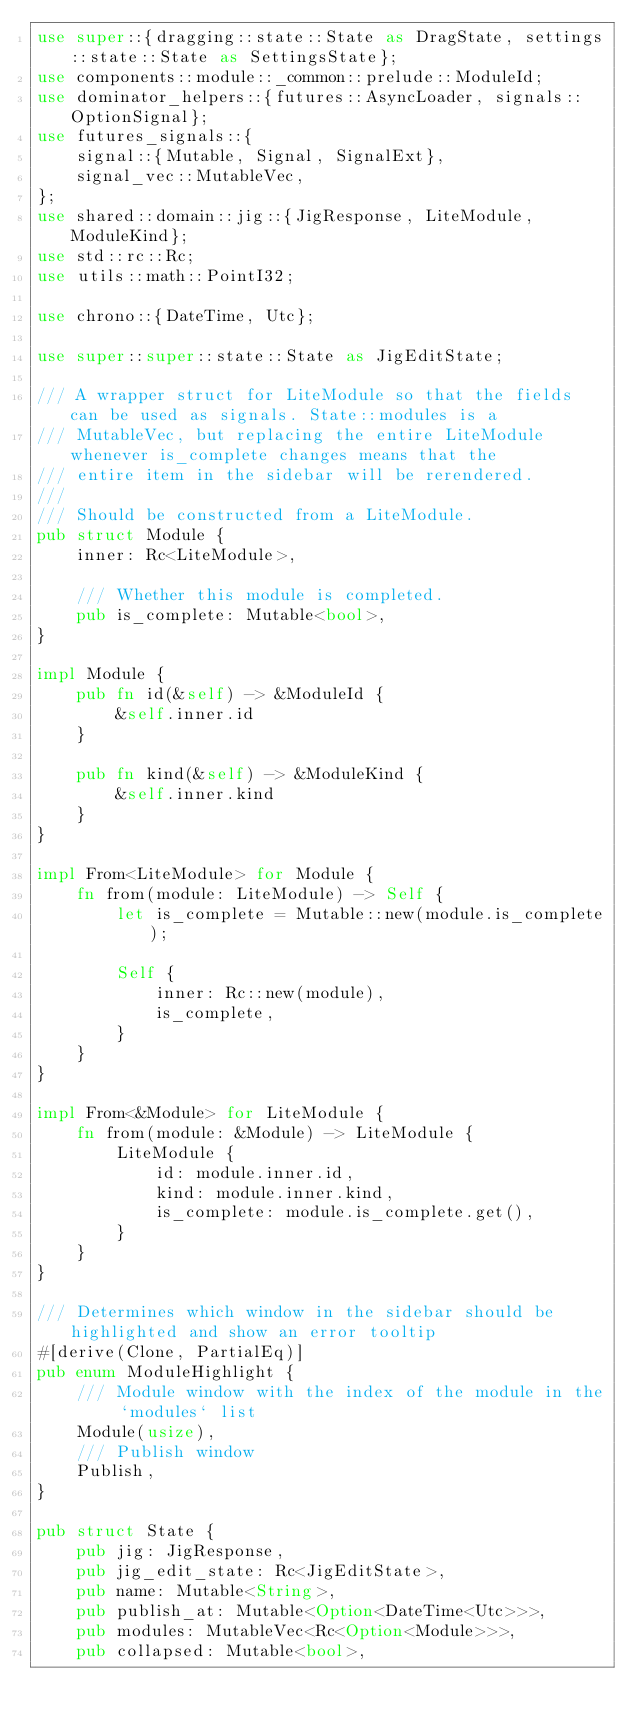<code> <loc_0><loc_0><loc_500><loc_500><_Rust_>use super::{dragging::state::State as DragState, settings::state::State as SettingsState};
use components::module::_common::prelude::ModuleId;
use dominator_helpers::{futures::AsyncLoader, signals::OptionSignal};
use futures_signals::{
    signal::{Mutable, Signal, SignalExt},
    signal_vec::MutableVec,
};
use shared::domain::jig::{JigResponse, LiteModule, ModuleKind};
use std::rc::Rc;
use utils::math::PointI32;

use chrono::{DateTime, Utc};

use super::super::state::State as JigEditState;

/// A wrapper struct for LiteModule so that the fields can be used as signals. State::modules is a
/// MutableVec, but replacing the entire LiteModule whenever is_complete changes means that the
/// entire item in the sidebar will be rerendered.
///
/// Should be constructed from a LiteModule.
pub struct Module {
    inner: Rc<LiteModule>,

    /// Whether this module is completed.
    pub is_complete: Mutable<bool>,
}

impl Module {
    pub fn id(&self) -> &ModuleId {
        &self.inner.id
    }

    pub fn kind(&self) -> &ModuleKind {
        &self.inner.kind
    }
}

impl From<LiteModule> for Module {
    fn from(module: LiteModule) -> Self {
        let is_complete = Mutable::new(module.is_complete);

        Self {
            inner: Rc::new(module),
            is_complete,
        }
    }
}

impl From<&Module> for LiteModule {
    fn from(module: &Module) -> LiteModule {
        LiteModule {
            id: module.inner.id,
            kind: module.inner.kind,
            is_complete: module.is_complete.get(),
        }
    }
}

/// Determines which window in the sidebar should be highlighted and show an error tooltip
#[derive(Clone, PartialEq)]
pub enum ModuleHighlight {
    /// Module window with the index of the module in the `modules` list
    Module(usize),
    /// Publish window
    Publish,
}

pub struct State {
    pub jig: JigResponse,
    pub jig_edit_state: Rc<JigEditState>,
    pub name: Mutable<String>,
    pub publish_at: Mutable<Option<DateTime<Utc>>>,
    pub modules: MutableVec<Rc<Option<Module>>>,
    pub collapsed: Mutable<bool>,</code> 